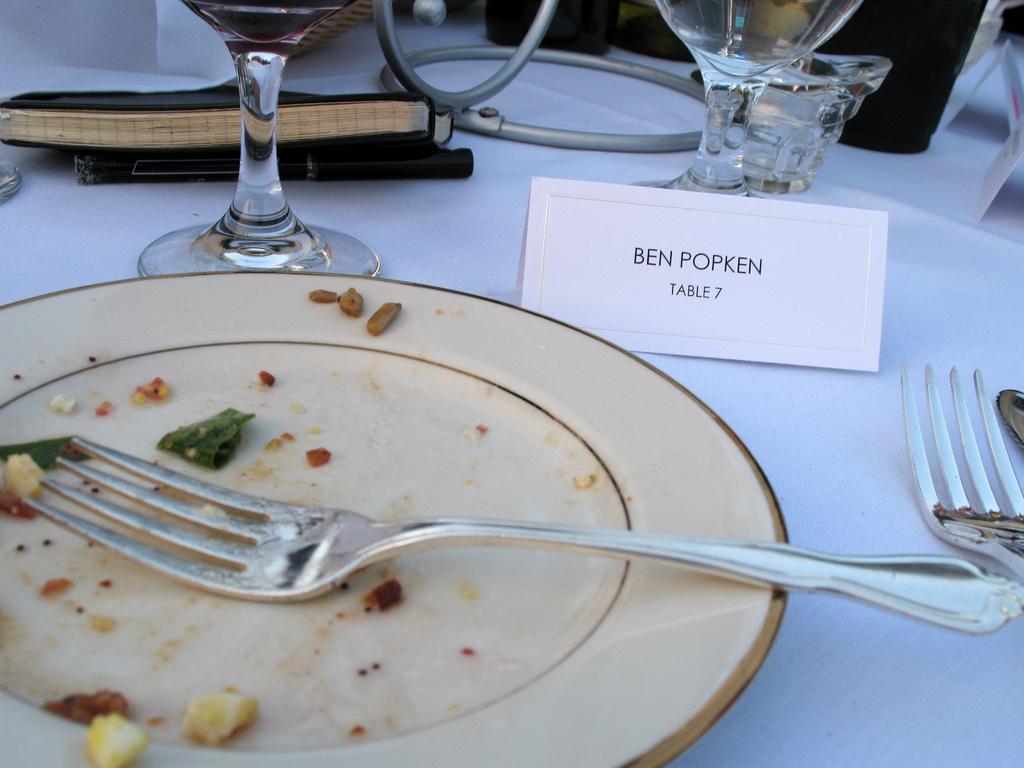Describe this image in one or two sentences. In this image I can see a white color plate and on it I can see a fork. On the right side of this image I can see one more fork and a silver color thing. On the top side of this image I can see few glasses, a diary, a pen, a white color board and on the board I can see something is written. 